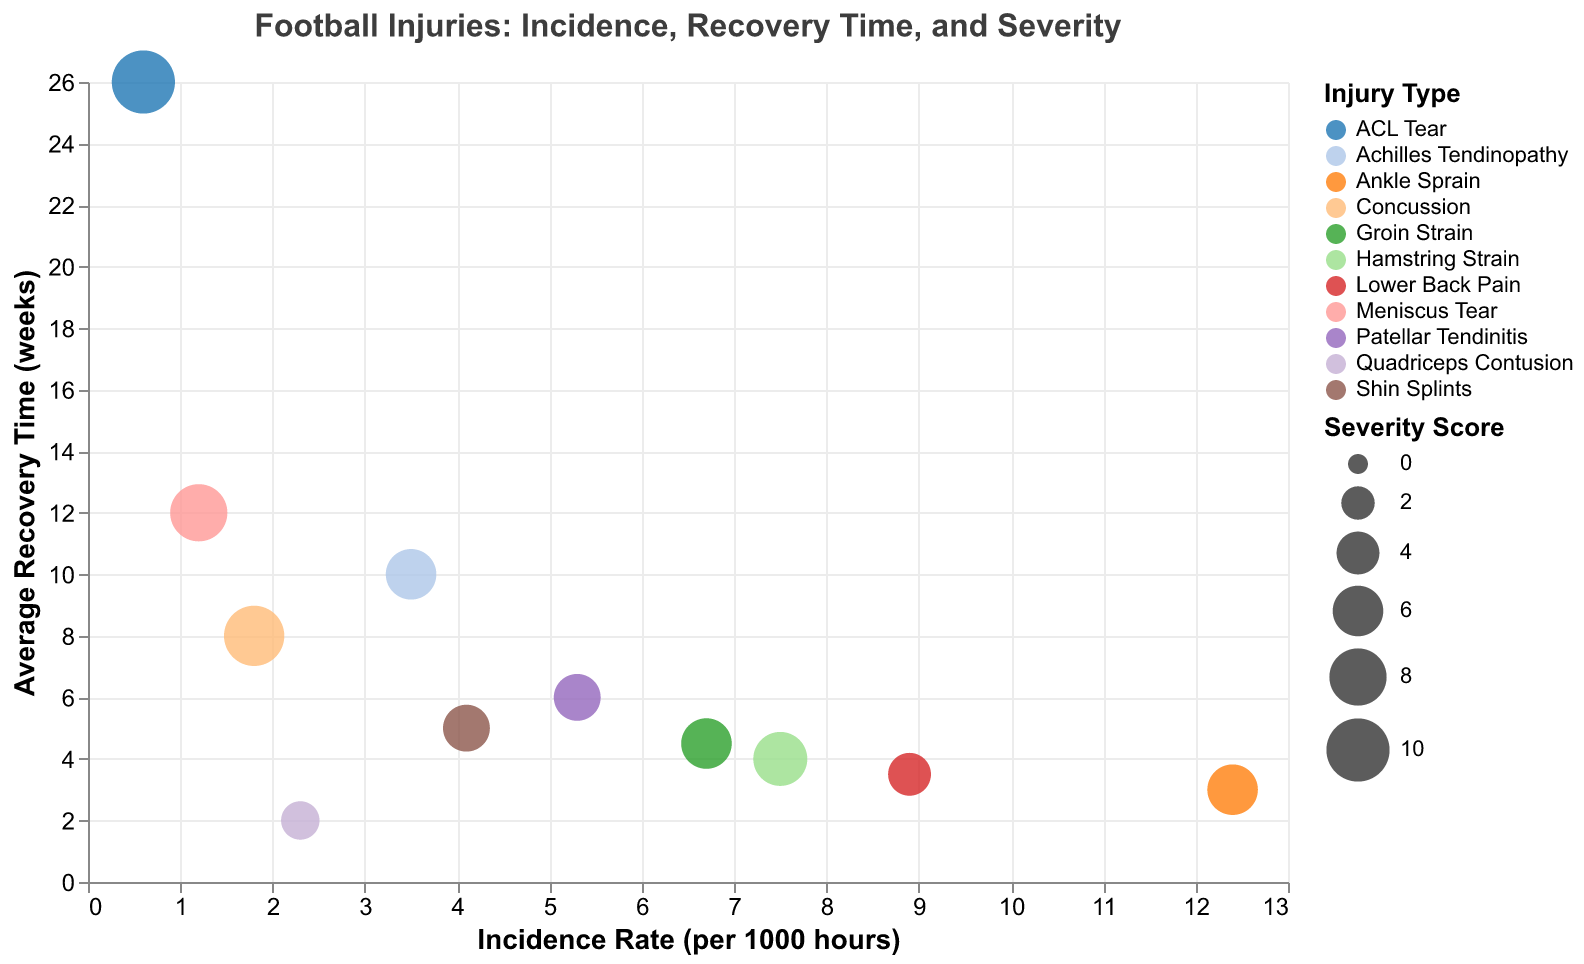What is the title of the chart? The title of the chart is located at the top and summarizes the content of the chart.
Answer: Football Injuries: Incidence, Recovery Time, and Severity Which injury type has the highest incidence rate? By looking at the x-axis, which represents the incidence rate, you find the data point farthest to the right.
Answer: Ankle Sprain Which injury type has the longest average recovery time? By looking at the y-axis, which represents the average recovery time, you find the data point located highest.
Answer: ACL Tear What is the incidence rate and average recovery time for Concussion? Locate the data point labeled "Concussion" on the chart and refer to its position on the x-axis and y-axis.
Answer: Incidence Rate: 1.8 per 1000 hours, Average Recovery Time: 8 weeks Which injury type has the highest severity score? The size of bubbles represents the severity score. Identify the largest bubble.
Answer: ACL Tear How does the average recovery time of Hamstring Strain compare to Groin Strain? Find both Hamstring Strain and Groin Strain on the chart and compare their positions on the y-axis.
Answer: Hamstring Strain: 4 weeks, Groin Strain: 4.5 weeks Which injury types have an average recovery time greater than 10 weeks? Locate and list the bubbles that are positioned above the "10 weeks" mark on the y-axis.
Answer: ACL Tear, Meniscus Tear What is the severity score for Lower Back Pain and how does it compare to Patellar Tendinitis? Refer to the bubble sizes for Lower Back Pain and Patellar Tendinitis and the legend for severity scores.
Answer: Lower Back Pain: 4, Patellar Tendinitis: 5 Which injury has a higher incidence rate: Lower Back Pain or Hamstring Strain? Look at the x-axis positions of both data points to compare.
Answer: Lower Back Pain Which injury type has an incidence rate higher than 10 per 1000 hours and a severity score of less than 7? Check for data points with an x-axis value greater than 10 and a bubble size indicating a severity score less than 7.
Answer: Ankle Sprain 